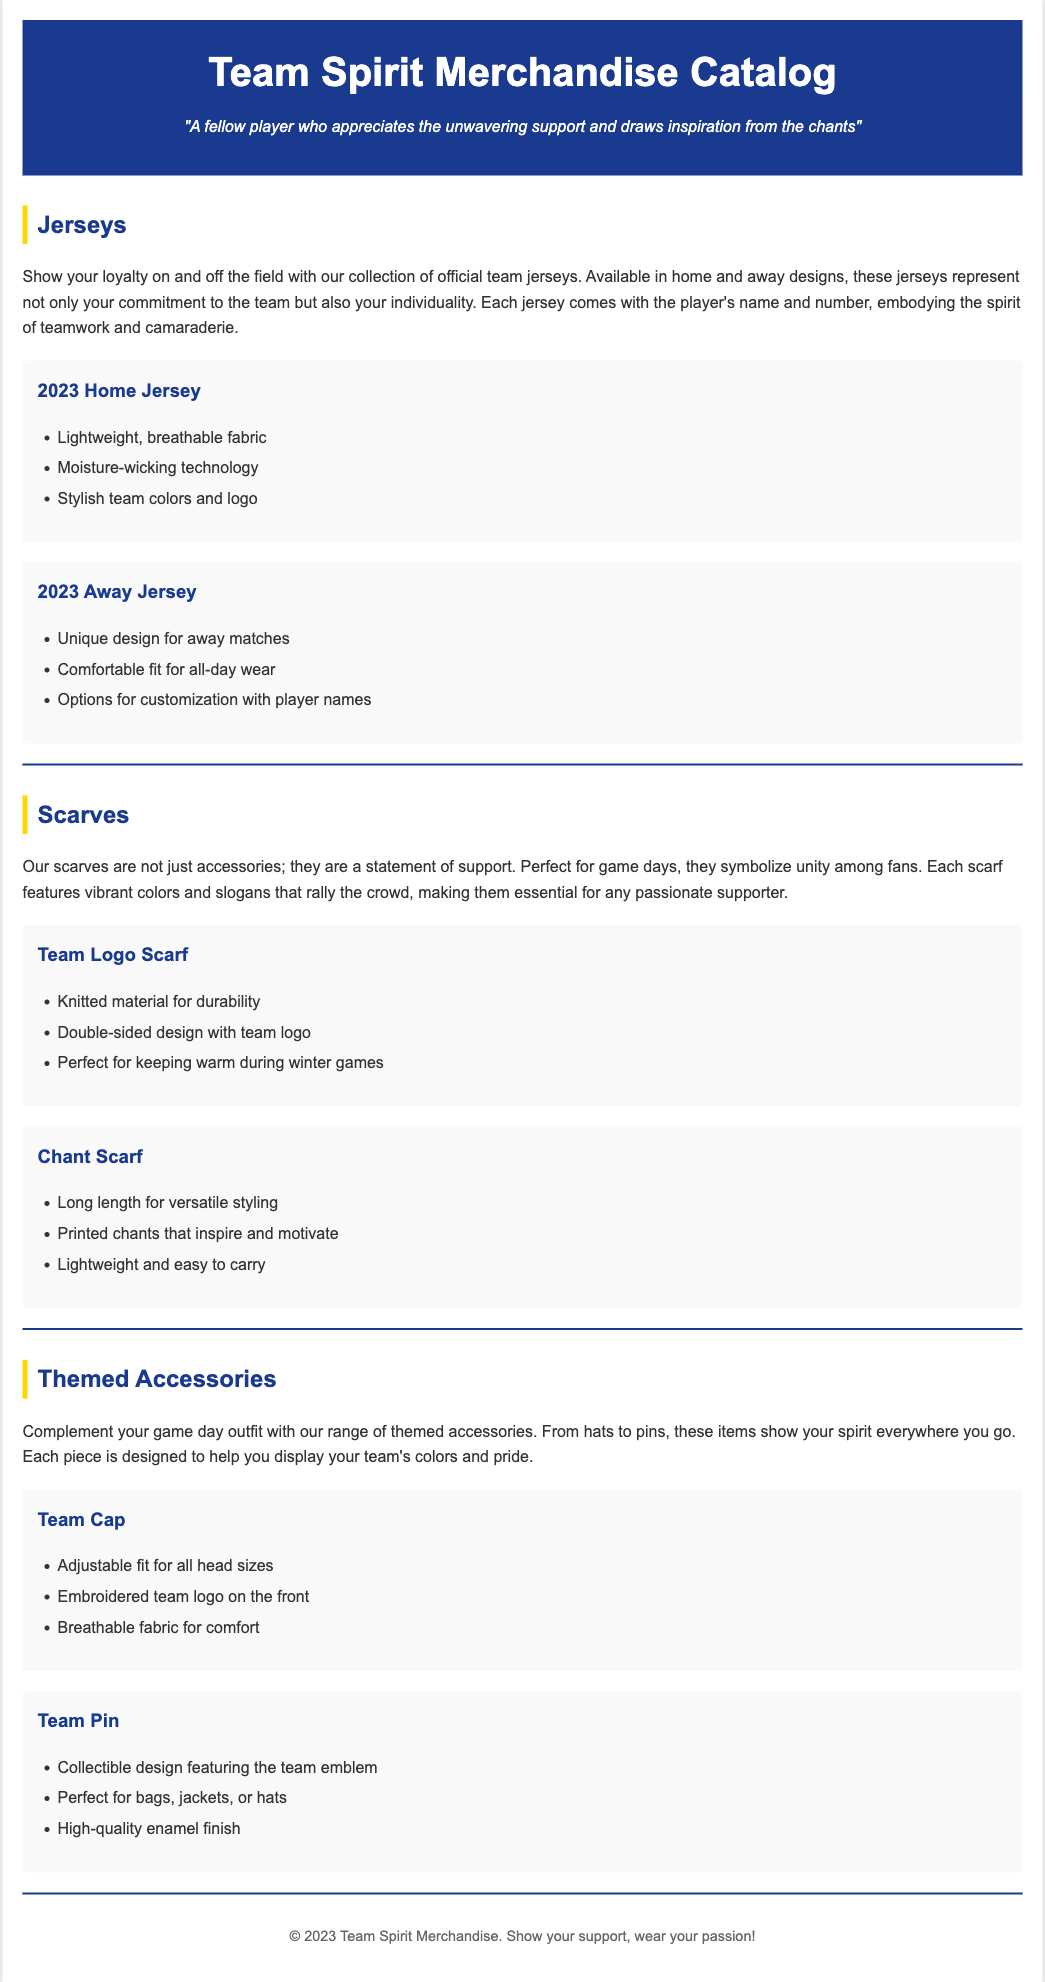What is the name of the catalog? The name of the catalog is displayed prominently at the top of the document.
Answer: Team Spirit Merchandise Catalog What types of jerseys are available? The document specifies two types of jerseys offered in the catalog.
Answer: Home and Away What technology is mentioned for the 2023 Home Jersey? The document highlights a specific feature that enhances the jersey's performance.
Answer: Moisture-wicking technology What is the material of the Team Logo Scarf? The document describes the material that ensures the scarf is durable.
Answer: Knitted material How does the Chant Scarf inspire fans? The description indicates a specific feature of the scarf that serves a motivational purpose.
Answer: Printed chants What accessory is adjustable for all head sizes? The document mentions a specific accessory that can fit various head sizes.
Answer: Team Cap How is the Team Pin described in terms of finish? The document provides details on the quality of the Team Pin.
Answer: High-quality enamel finish What does each jersey symbolize according to the document? The description emphasizes a concept represented by the jerseys.
Answer: Teamwork and camaraderie 